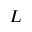<formula> <loc_0><loc_0><loc_500><loc_500>L</formula> 